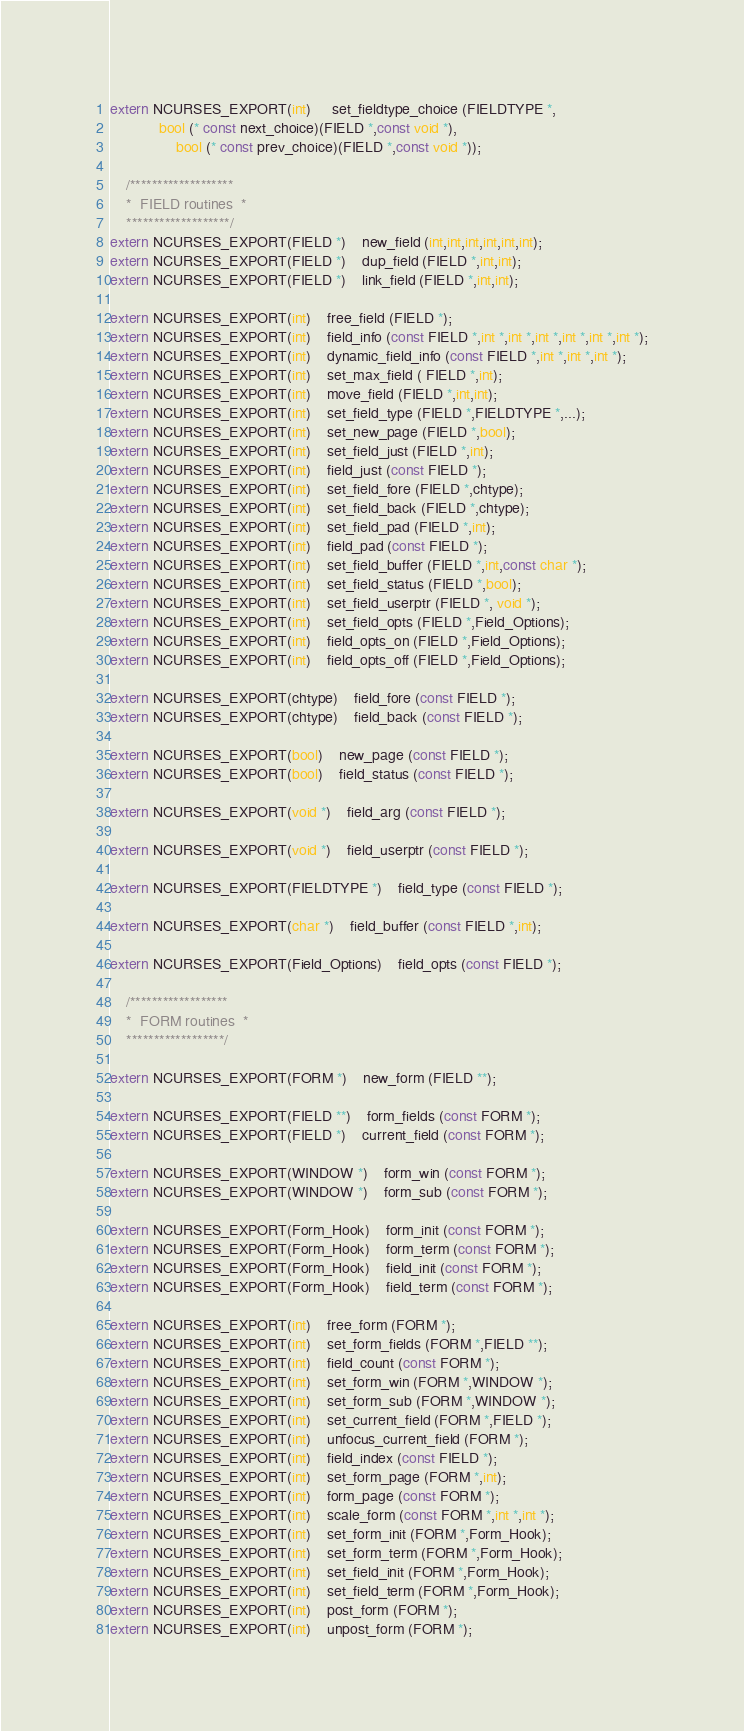Convert code to text. <code><loc_0><loc_0><loc_500><loc_500><_C_>extern NCURSES_EXPORT(int)	 set_fieldtype_choice (FIELDTYPE *,
		    bool (* const next_choice)(FIELD *,const void *),
	      	    bool (* const prev_choice)(FIELD *,const void *));

	/*******************
	*  FIELD routines  *
	*******************/
extern NCURSES_EXPORT(FIELD *)	new_field (int,int,int,int,int,int);
extern NCURSES_EXPORT(FIELD *)	dup_field (FIELD *,int,int);
extern NCURSES_EXPORT(FIELD *)	link_field (FIELD *,int,int);

extern NCURSES_EXPORT(int)	free_field (FIELD *);
extern NCURSES_EXPORT(int)	field_info (const FIELD *,int *,int *,int *,int *,int *,int *);
extern NCURSES_EXPORT(int)	dynamic_field_info (const FIELD *,int *,int *,int *);
extern NCURSES_EXPORT(int)	set_max_field ( FIELD *,int);
extern NCURSES_EXPORT(int)	move_field (FIELD *,int,int);
extern NCURSES_EXPORT(int)	set_field_type (FIELD *,FIELDTYPE *,...);
extern NCURSES_EXPORT(int)	set_new_page (FIELD *,bool);
extern NCURSES_EXPORT(int)	set_field_just (FIELD *,int);
extern NCURSES_EXPORT(int)	field_just (const FIELD *);
extern NCURSES_EXPORT(int)	set_field_fore (FIELD *,chtype);
extern NCURSES_EXPORT(int)	set_field_back (FIELD *,chtype);
extern NCURSES_EXPORT(int)	set_field_pad (FIELD *,int);
extern NCURSES_EXPORT(int)	field_pad (const FIELD *);
extern NCURSES_EXPORT(int)	set_field_buffer (FIELD *,int,const char *);
extern NCURSES_EXPORT(int)	set_field_status (FIELD *,bool);
extern NCURSES_EXPORT(int)	set_field_userptr (FIELD *, void *);
extern NCURSES_EXPORT(int)	set_field_opts (FIELD *,Field_Options);
extern NCURSES_EXPORT(int)	field_opts_on (FIELD *,Field_Options);
extern NCURSES_EXPORT(int)	field_opts_off (FIELD *,Field_Options);

extern NCURSES_EXPORT(chtype)	field_fore (const FIELD *);
extern NCURSES_EXPORT(chtype)	field_back (const FIELD *);

extern NCURSES_EXPORT(bool)	new_page (const FIELD *);
extern NCURSES_EXPORT(bool)	field_status (const FIELD *);

extern NCURSES_EXPORT(void *)	field_arg (const FIELD *);

extern NCURSES_EXPORT(void *)	field_userptr (const FIELD *);

extern NCURSES_EXPORT(FIELDTYPE *)	field_type (const FIELD *);

extern NCURSES_EXPORT(char *)	field_buffer (const FIELD *,int);

extern NCURSES_EXPORT(Field_Options)	field_opts (const FIELD *);

	/******************
	*  FORM routines  *
	******************/

extern NCURSES_EXPORT(FORM *)	new_form (FIELD **);

extern NCURSES_EXPORT(FIELD **)	form_fields (const FORM *);
extern NCURSES_EXPORT(FIELD *)	current_field (const FORM *);

extern NCURSES_EXPORT(WINDOW *)	form_win (const FORM *);
extern NCURSES_EXPORT(WINDOW *)	form_sub (const FORM *);

extern NCURSES_EXPORT(Form_Hook)	form_init (const FORM *);
extern NCURSES_EXPORT(Form_Hook)	form_term (const FORM *);
extern NCURSES_EXPORT(Form_Hook)	field_init (const FORM *);
extern NCURSES_EXPORT(Form_Hook)	field_term (const FORM *);

extern NCURSES_EXPORT(int)	free_form (FORM *);
extern NCURSES_EXPORT(int)	set_form_fields (FORM *,FIELD **);
extern NCURSES_EXPORT(int)	field_count (const FORM *);
extern NCURSES_EXPORT(int)	set_form_win (FORM *,WINDOW *);
extern NCURSES_EXPORT(int)	set_form_sub (FORM *,WINDOW *);
extern NCURSES_EXPORT(int)	set_current_field (FORM *,FIELD *);
extern NCURSES_EXPORT(int)	unfocus_current_field (FORM *);
extern NCURSES_EXPORT(int)	field_index (const FIELD *);
extern NCURSES_EXPORT(int)	set_form_page (FORM *,int);
extern NCURSES_EXPORT(int)	form_page (const FORM *);
extern NCURSES_EXPORT(int)	scale_form (const FORM *,int *,int *);
extern NCURSES_EXPORT(int)	set_form_init (FORM *,Form_Hook);
extern NCURSES_EXPORT(int)	set_form_term (FORM *,Form_Hook);
extern NCURSES_EXPORT(int)	set_field_init (FORM *,Form_Hook);
extern NCURSES_EXPORT(int)	set_field_term (FORM *,Form_Hook);
extern NCURSES_EXPORT(int)	post_form (FORM *);
extern NCURSES_EXPORT(int)	unpost_form (FORM *);</code> 